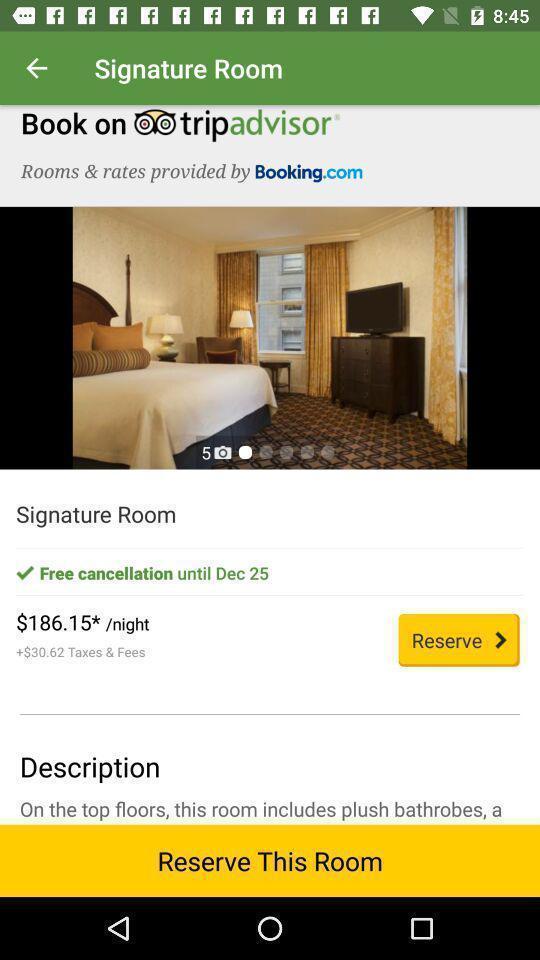What details can you identify in this image? Screen displaying hotel booking information with price. 